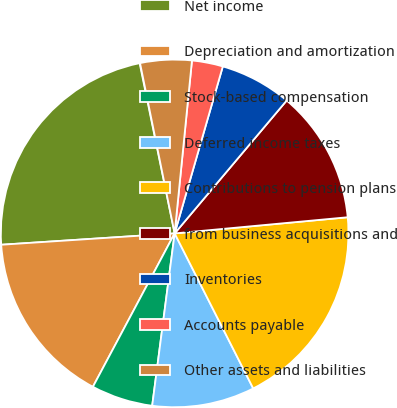Convert chart. <chart><loc_0><loc_0><loc_500><loc_500><pie_chart><fcel>For the years ended December<fcel>Net income<fcel>Depreciation and amortization<fcel>Stock-based compensation<fcel>Deferred income taxes<fcel>Contributions to pension plans<fcel>from business acquisitions and<fcel>Inventories<fcel>Accounts payable<fcel>Other assets and liabilities<nl><fcel>0.04%<fcel>22.81%<fcel>16.17%<fcel>5.73%<fcel>9.53%<fcel>19.02%<fcel>12.37%<fcel>6.68%<fcel>2.88%<fcel>4.78%<nl></chart> 